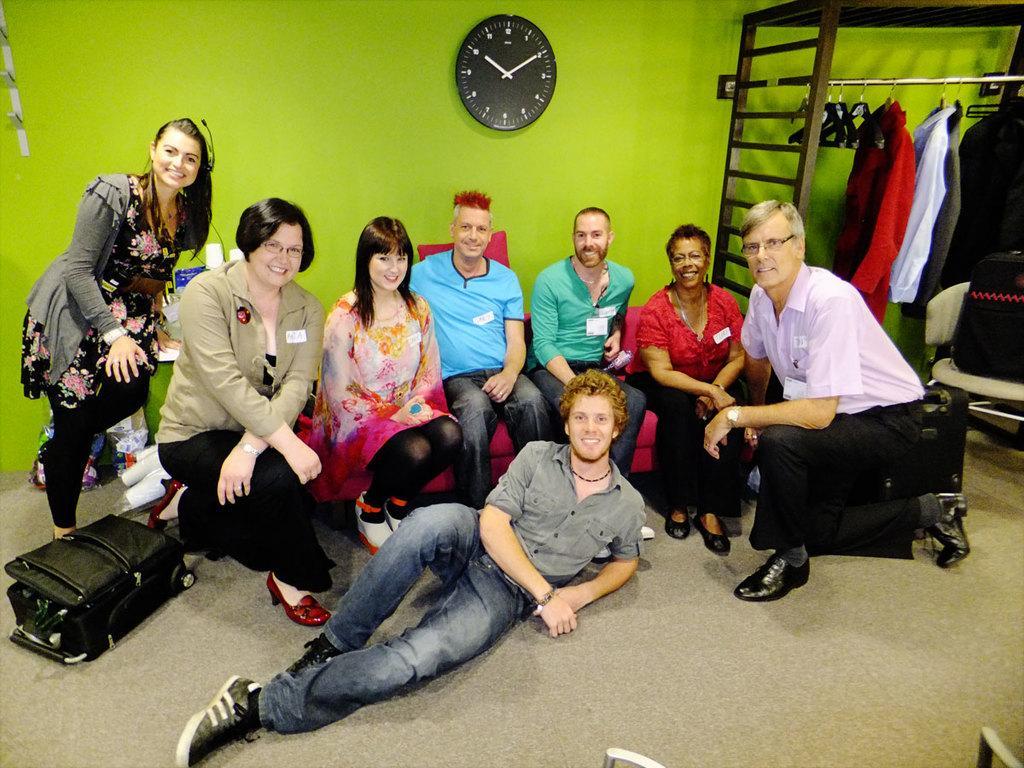How would you summarize this image in a sentence or two? In this picture we can see many people in a room looking and smiling at someone. In the background, we can see a wall clock and clothes. 